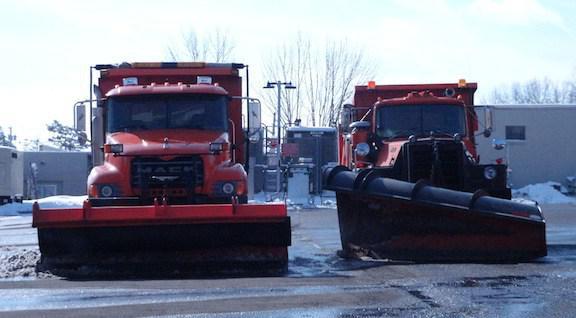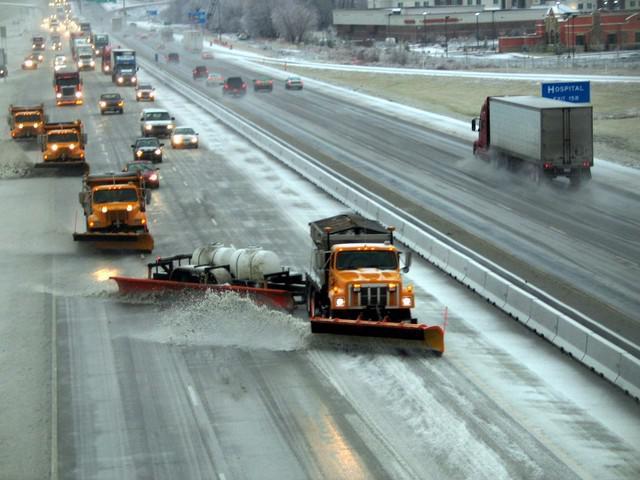The first image is the image on the left, the second image is the image on the right. Assess this claim about the two images: "The left and right image contains the same number of snow truck with at least one with an orange plow.". Correct or not? Answer yes or no. No. The first image is the image on the left, the second image is the image on the right. Analyze the images presented: Is the assertion "Each image shows a truck with a red-orange front plow angled facing rightward, and one image features an orange truck pulling a plow." valid? Answer yes or no. No. 